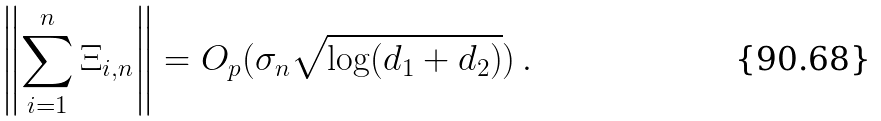Convert formula to latex. <formula><loc_0><loc_0><loc_500><loc_500>\left \| \sum _ { i = 1 } ^ { n } \Xi _ { i , n } \right \| = O _ { p } ( \sigma _ { n } \sqrt { \log ( d _ { 1 } + d _ { 2 } ) } ) \, .</formula> 